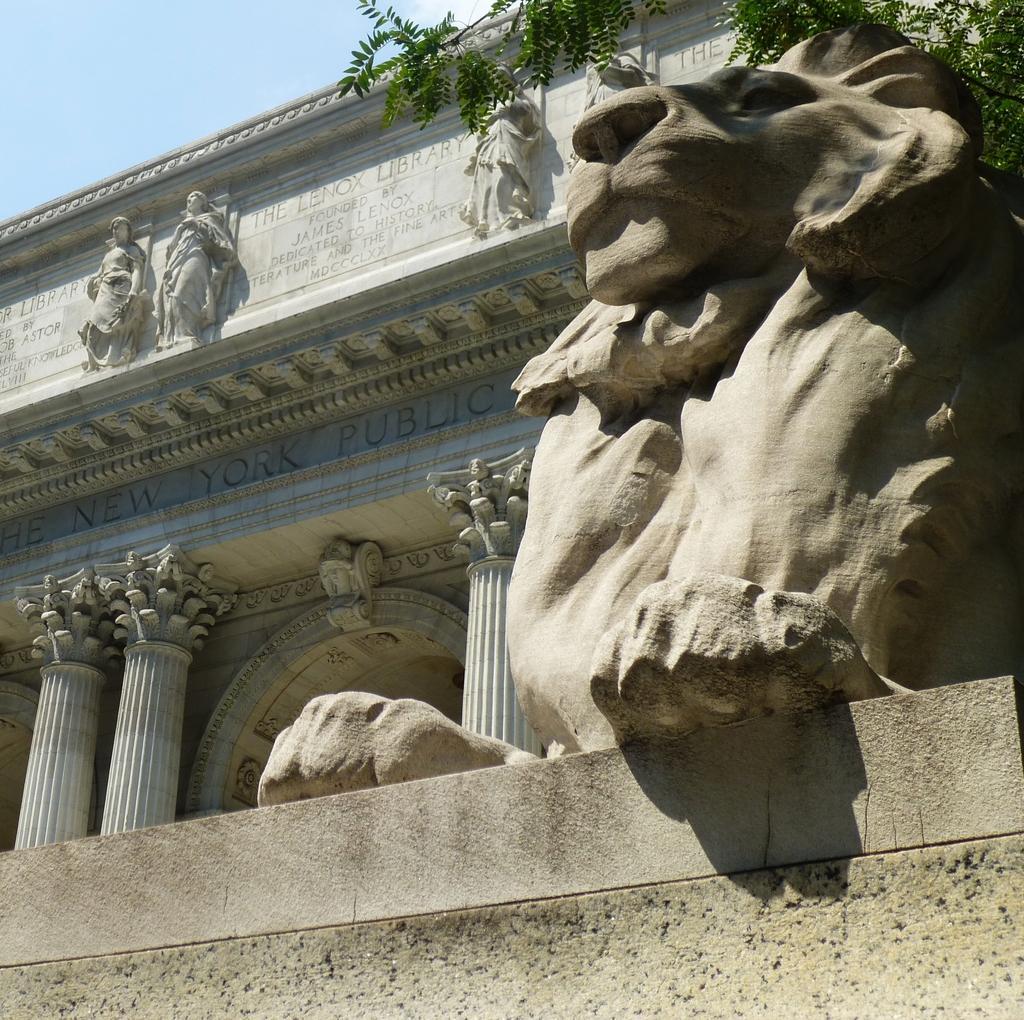Describe this image in one or two sentences. As we can see in the image there are statues, building, tree and sky. 